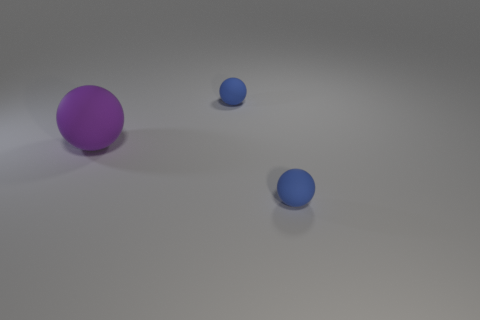Are these objects casting any shadows? Yes, each of the spherical objects is casting a subtle shadow on the ground that suggests a light source located above them. 